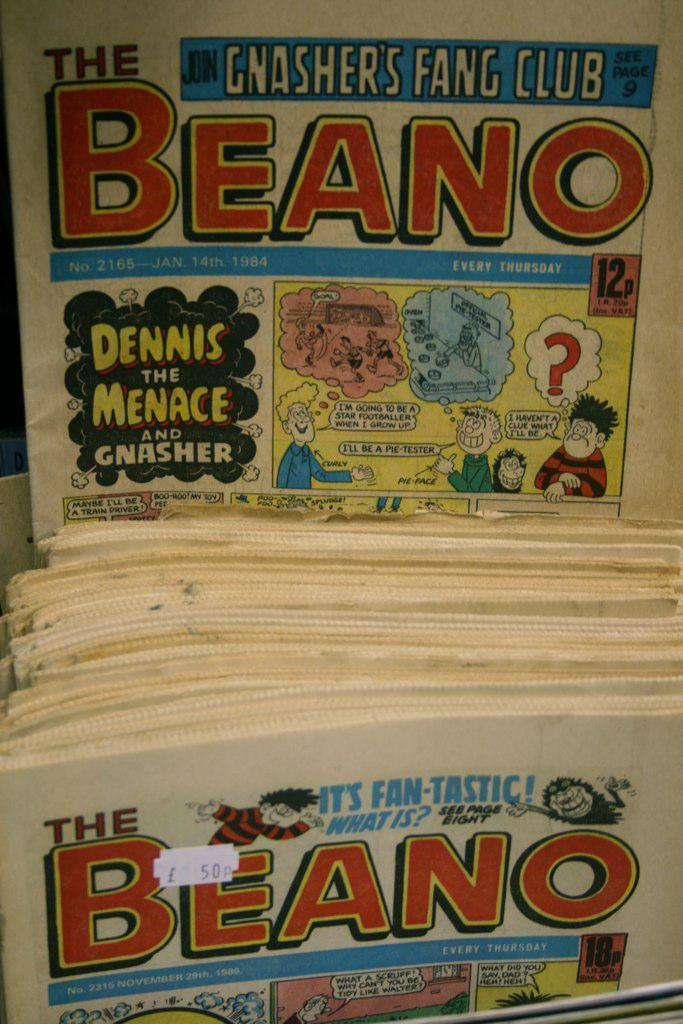<image>
Write a terse but informative summary of the picture. Stacks of a comic magazine with the name Beano on the front. 